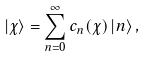Convert formula to latex. <formula><loc_0><loc_0><loc_500><loc_500>\left | \chi \right > = \sum _ { n = 0 } ^ { \infty } c _ { n } ( \chi ) \left | n \right > ,</formula> 